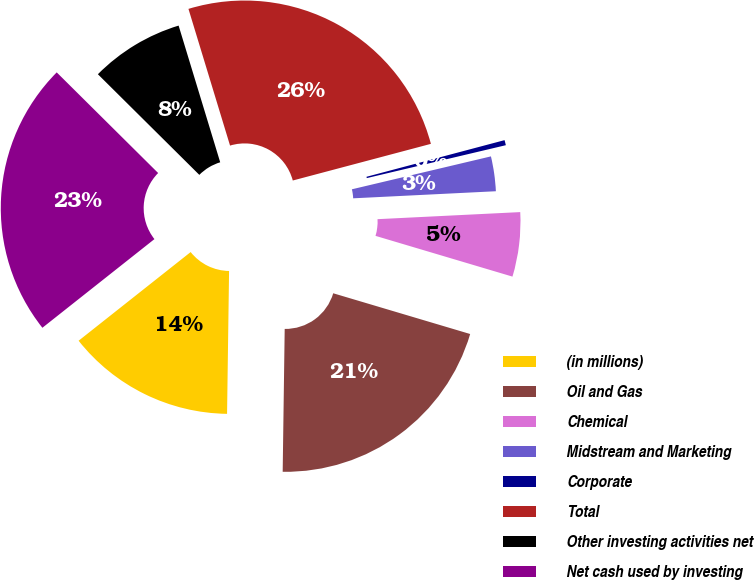Convert chart to OTSL. <chart><loc_0><loc_0><loc_500><loc_500><pie_chart><fcel>(in millions)<fcel>Oil and Gas<fcel>Chemical<fcel>Midstream and Marketing<fcel>Corporate<fcel>Total<fcel>Other investing activities net<fcel>Net cash used by investing<nl><fcel>14.12%<fcel>20.62%<fcel>5.39%<fcel>2.91%<fcel>0.43%<fcel>25.57%<fcel>7.86%<fcel>23.09%<nl></chart> 